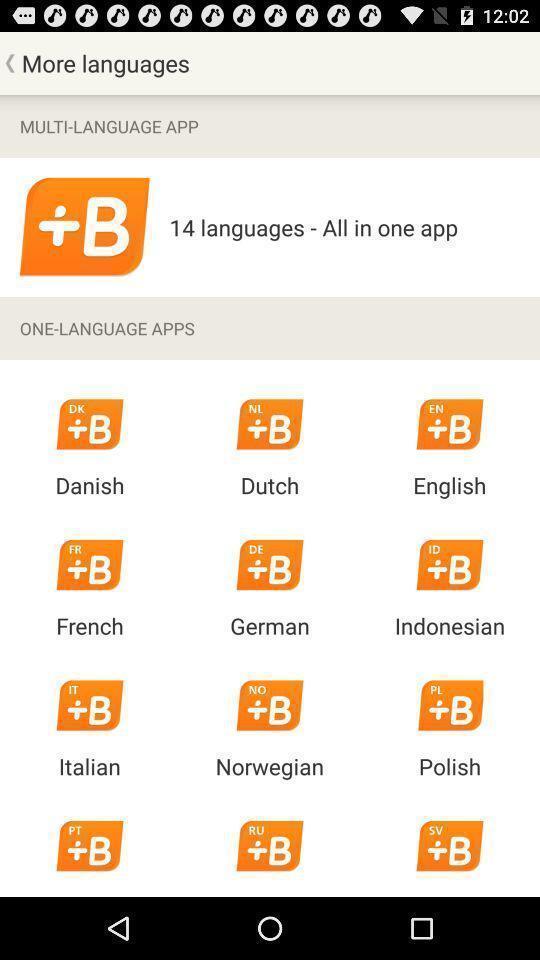Explain the elements present in this screenshot. Screen displaying multi language app in a mobile. 